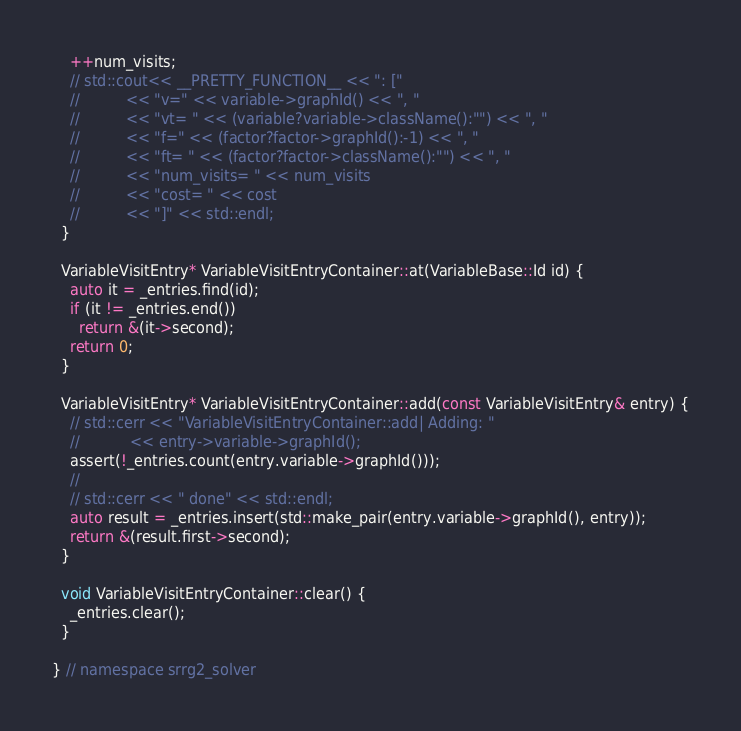<code> <loc_0><loc_0><loc_500><loc_500><_C++_>    ++num_visits;
    // std::cout<< __PRETTY_FUNCTION__ << ": ["
    //          << "v=" << variable->graphId() << ", "
    //          << "vt= " << (variable?variable->className():"") << ", "
    //          << "f=" << (factor?factor->graphId():-1) << ", "
    //          << "ft= " << (factor?factor->className():"") << ", "
    //          << "num_visits= " << num_visits
    //          << "cost= " << cost
    //          << "]" << std::endl;
  }

  VariableVisitEntry* VariableVisitEntryContainer::at(VariableBase::Id id) {
    auto it = _entries.find(id);
    if (it != _entries.end())
      return &(it->second);
    return 0;
  }

  VariableVisitEntry* VariableVisitEntryContainer::add(const VariableVisitEntry& entry) {
    // std::cerr << "VariableVisitEntryContainer::add| Adding: "
    //           << entry->variable->graphId();
    assert(!_entries.count(entry.variable->graphId()));
    //
    // std::cerr << " done" << std::endl;
    auto result = _entries.insert(std::make_pair(entry.variable->graphId(), entry));
    return &(result.first->second);
  }

  void VariableVisitEntryContainer::clear() {
    _entries.clear();
  }

} // namespace srrg2_solver
</code> 